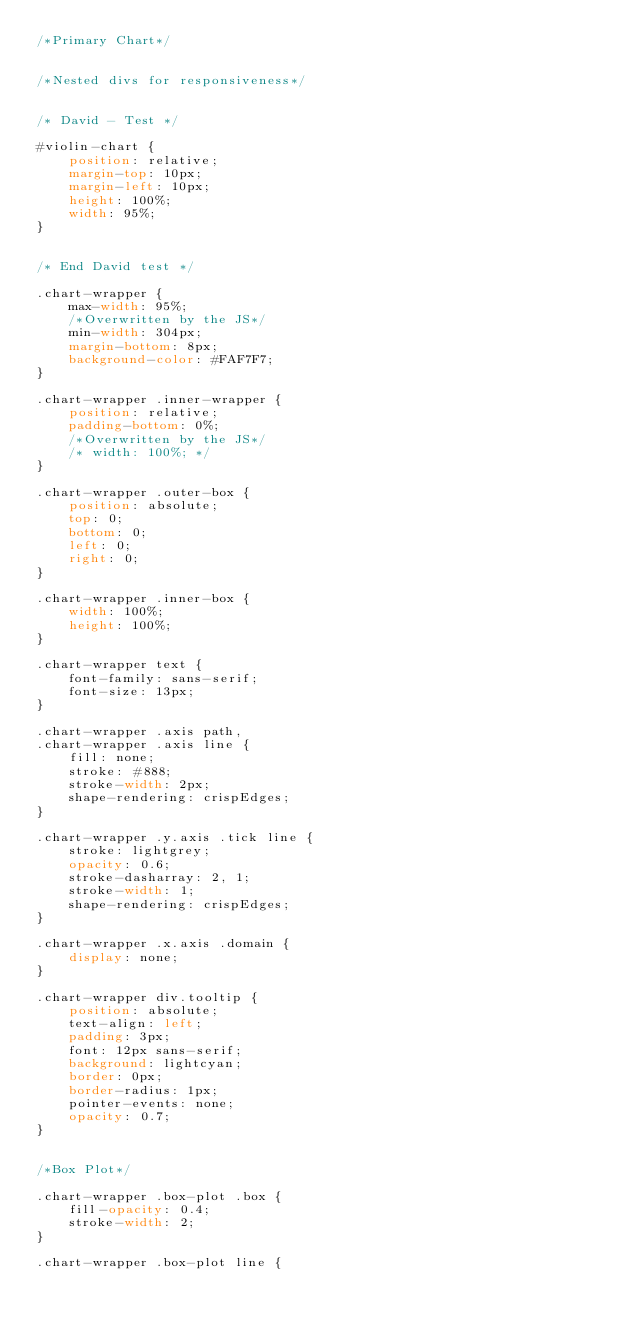<code> <loc_0><loc_0><loc_500><loc_500><_CSS_>/*Primary Chart*/


/*Nested divs for responsiveness*/


/* David - Test */

#violin-chart {
    position: relative;
    margin-top: 10px;
    margin-left: 10px;
    height: 100%;
    width: 95%;
}


/* End David test */

.chart-wrapper {
    max-width: 95%;
    /*Overwritten by the JS*/
    min-width: 304px;
    margin-bottom: 8px;
    background-color: #FAF7F7;
}

.chart-wrapper .inner-wrapper {
    position: relative;
    padding-bottom: 0%;
    /*Overwritten by the JS*/
    /* width: 100%; */
}

.chart-wrapper .outer-box {
    position: absolute;
    top: 0;
    bottom: 0;
    left: 0;
    right: 0;
}

.chart-wrapper .inner-box {
    width: 100%;
    height: 100%;
}

.chart-wrapper text {
    font-family: sans-serif;
    font-size: 13px;
}

.chart-wrapper .axis path,
.chart-wrapper .axis line {
    fill: none;
    stroke: #888;
    stroke-width: 2px;
    shape-rendering: crispEdges;
}

.chart-wrapper .y.axis .tick line {
    stroke: lightgrey;
    opacity: 0.6;
    stroke-dasharray: 2, 1;
    stroke-width: 1;
    shape-rendering: crispEdges;
}

.chart-wrapper .x.axis .domain {
    display: none;
}

.chart-wrapper div.tooltip {
    position: absolute;
    text-align: left;
    padding: 3px;
    font: 12px sans-serif;
    background: lightcyan;
    border: 0px;
    border-radius: 1px;
    pointer-events: none;
    opacity: 0.7;
}


/*Box Plot*/

.chart-wrapper .box-plot .box {
    fill-opacity: 0.4;
    stroke-width: 2;
}

.chart-wrapper .box-plot line {</code> 